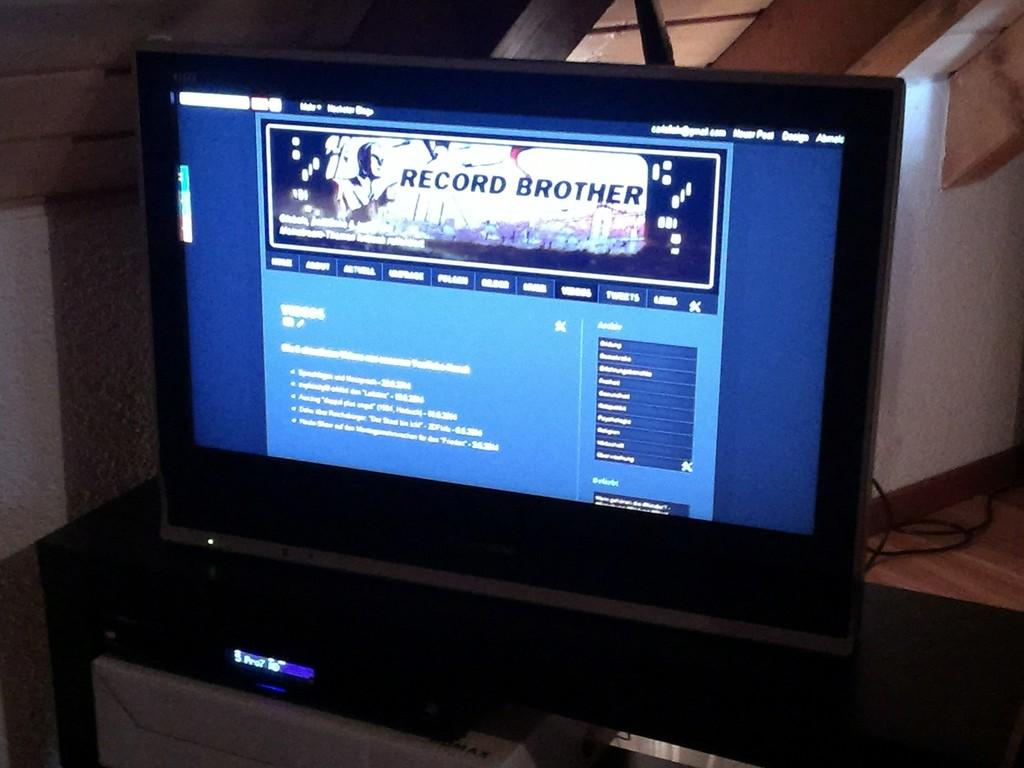What is the web page's name?
Ensure brevity in your answer.  Record brother. 